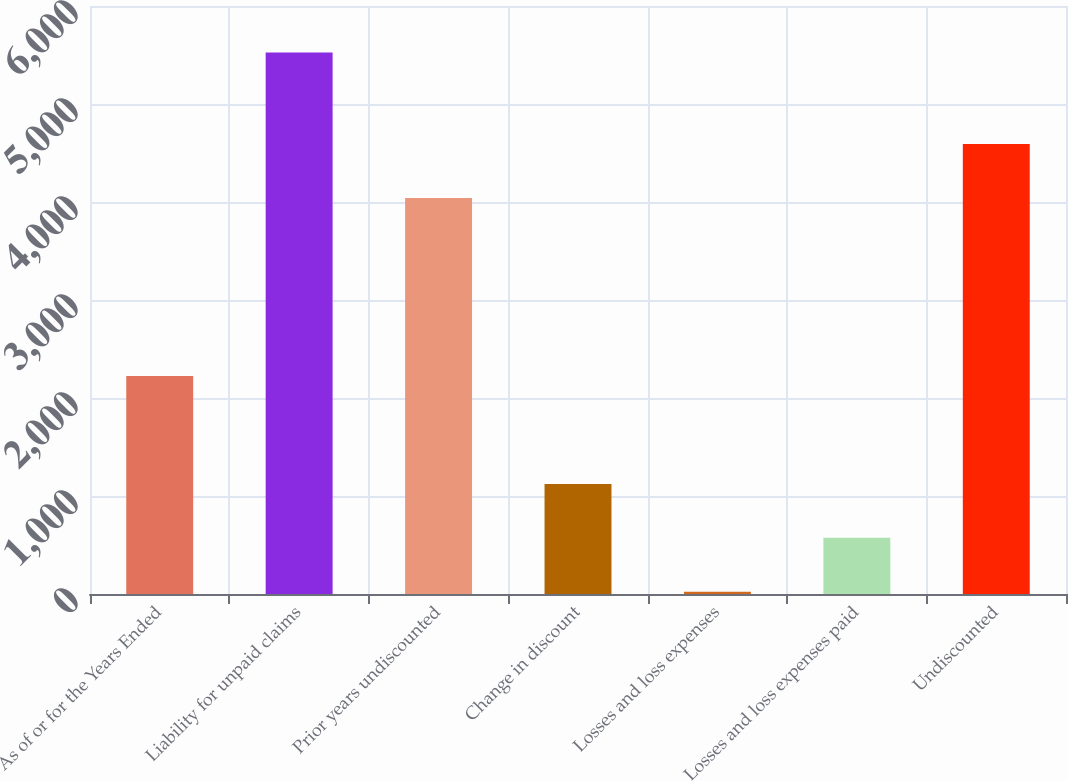Convert chart to OTSL. <chart><loc_0><loc_0><loc_500><loc_500><bar_chart><fcel>As of or for the Years Ended<fcel>Liability for unpaid claims<fcel>Prior years undiscounted<fcel>Change in discount<fcel>Losses and loss expenses<fcel>Losses and loss expenses paid<fcel>Undiscounted<nl><fcel>2224.2<fcel>5526<fcel>4040.6<fcel>1123.6<fcel>23<fcel>573.3<fcel>4590.9<nl></chart> 